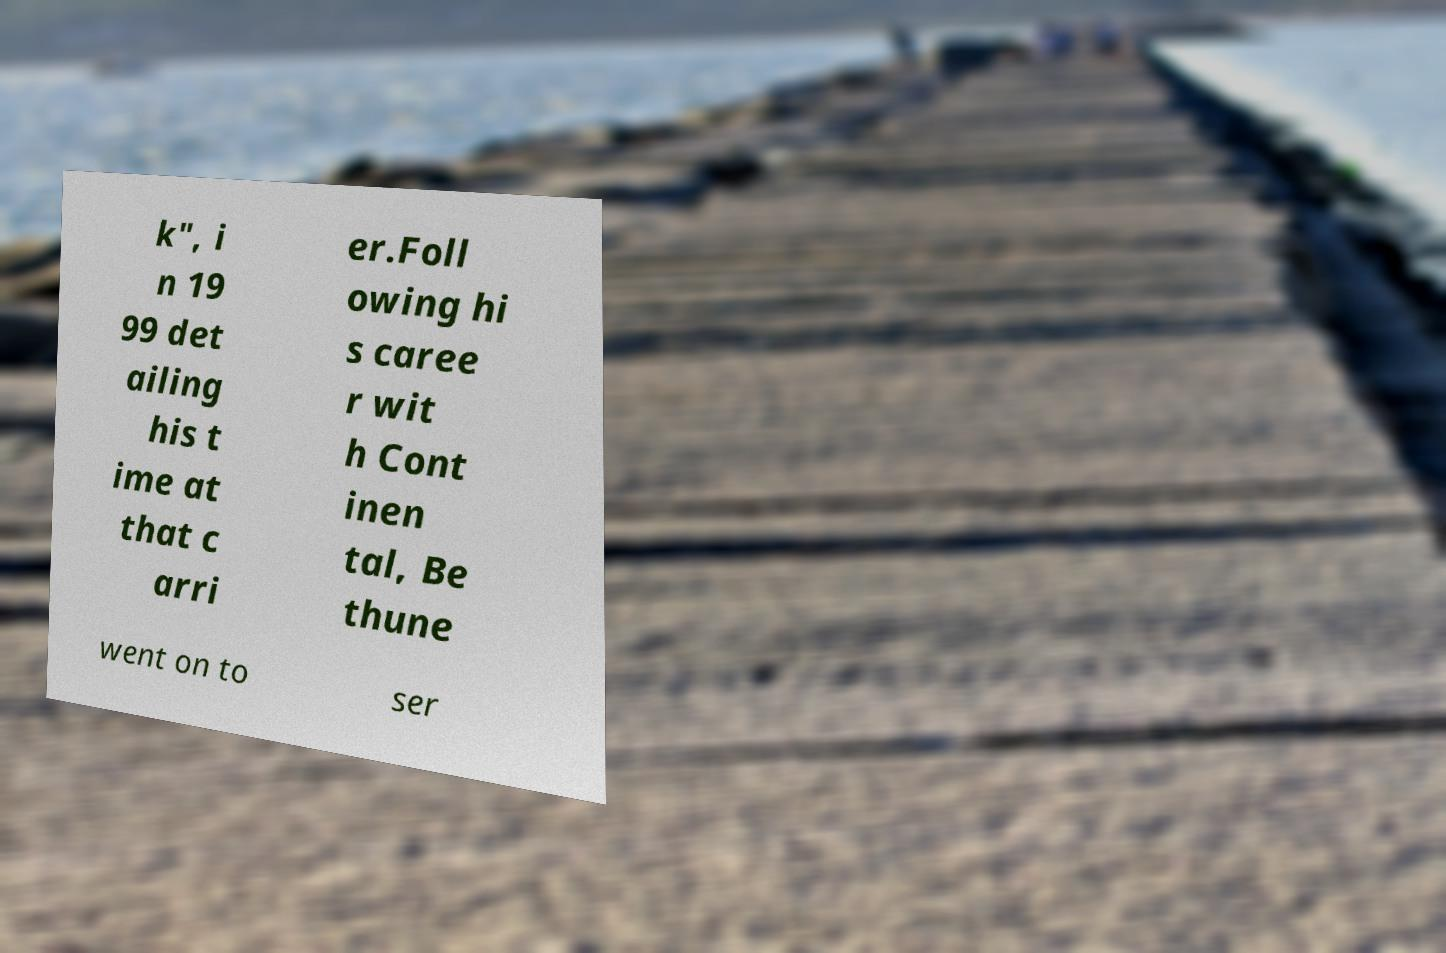Please identify and transcribe the text found in this image. k", i n 19 99 det ailing his t ime at that c arri er.Foll owing hi s caree r wit h Cont inen tal, Be thune went on to ser 